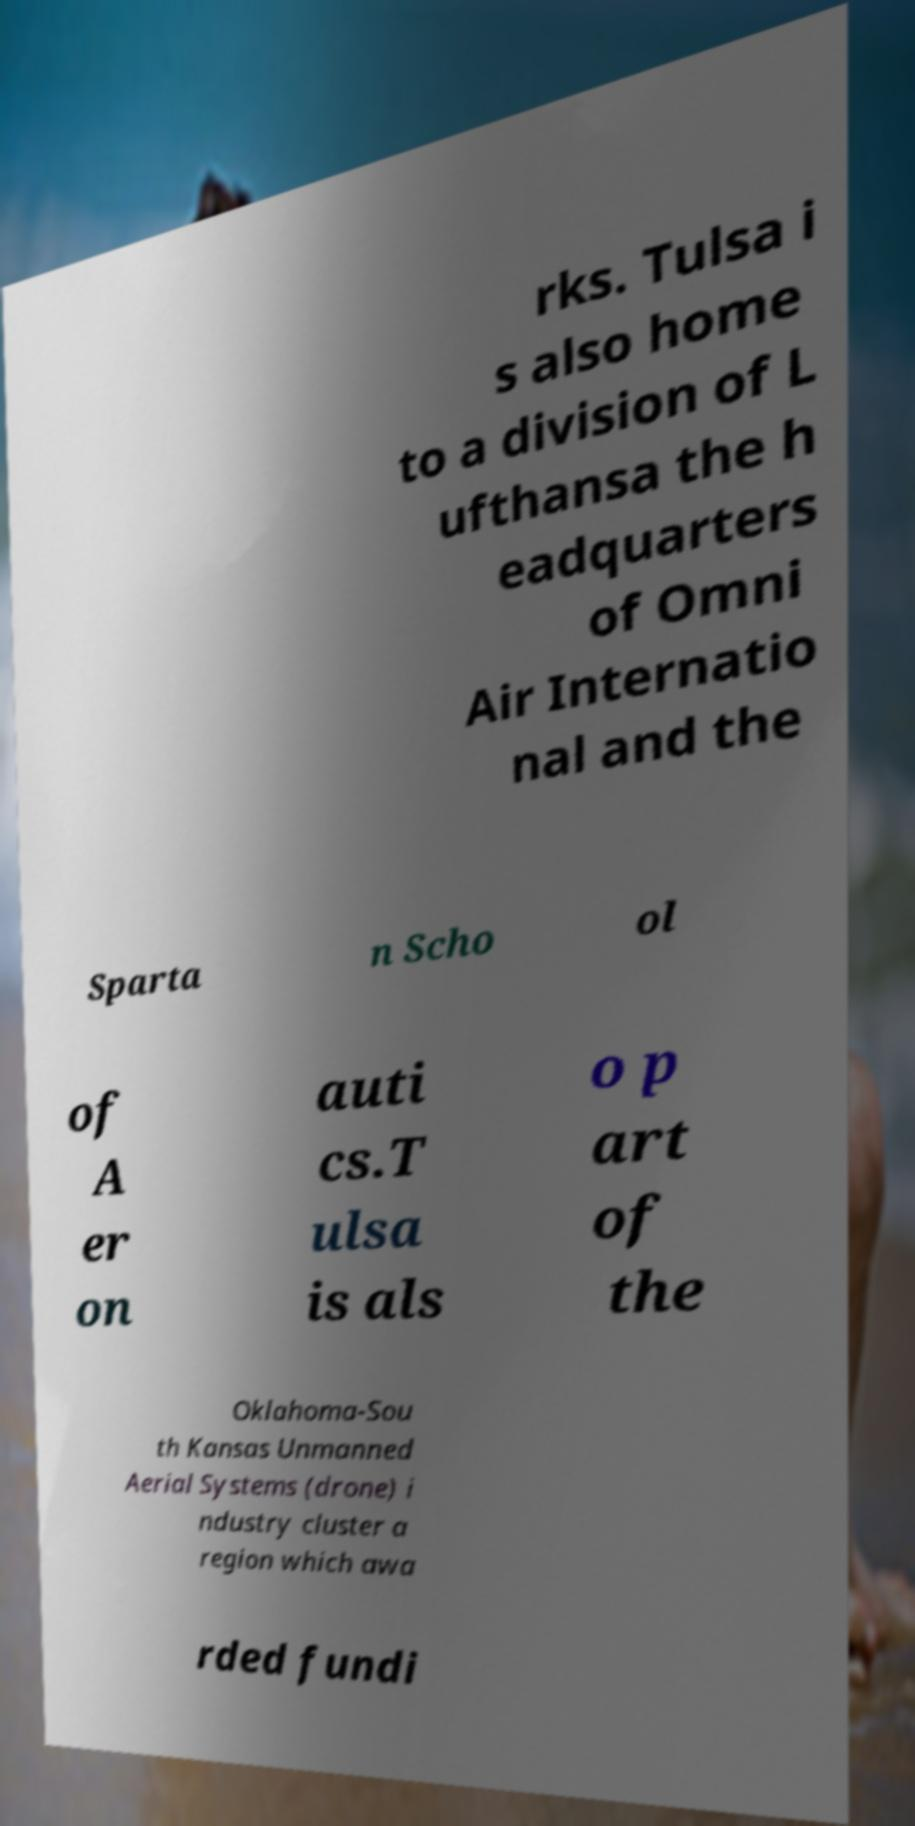Please identify and transcribe the text found in this image. rks. Tulsa i s also home to a division of L ufthansa the h eadquarters of Omni Air Internatio nal and the Sparta n Scho ol of A er on auti cs.T ulsa is als o p art of the Oklahoma-Sou th Kansas Unmanned Aerial Systems (drone) i ndustry cluster a region which awa rded fundi 